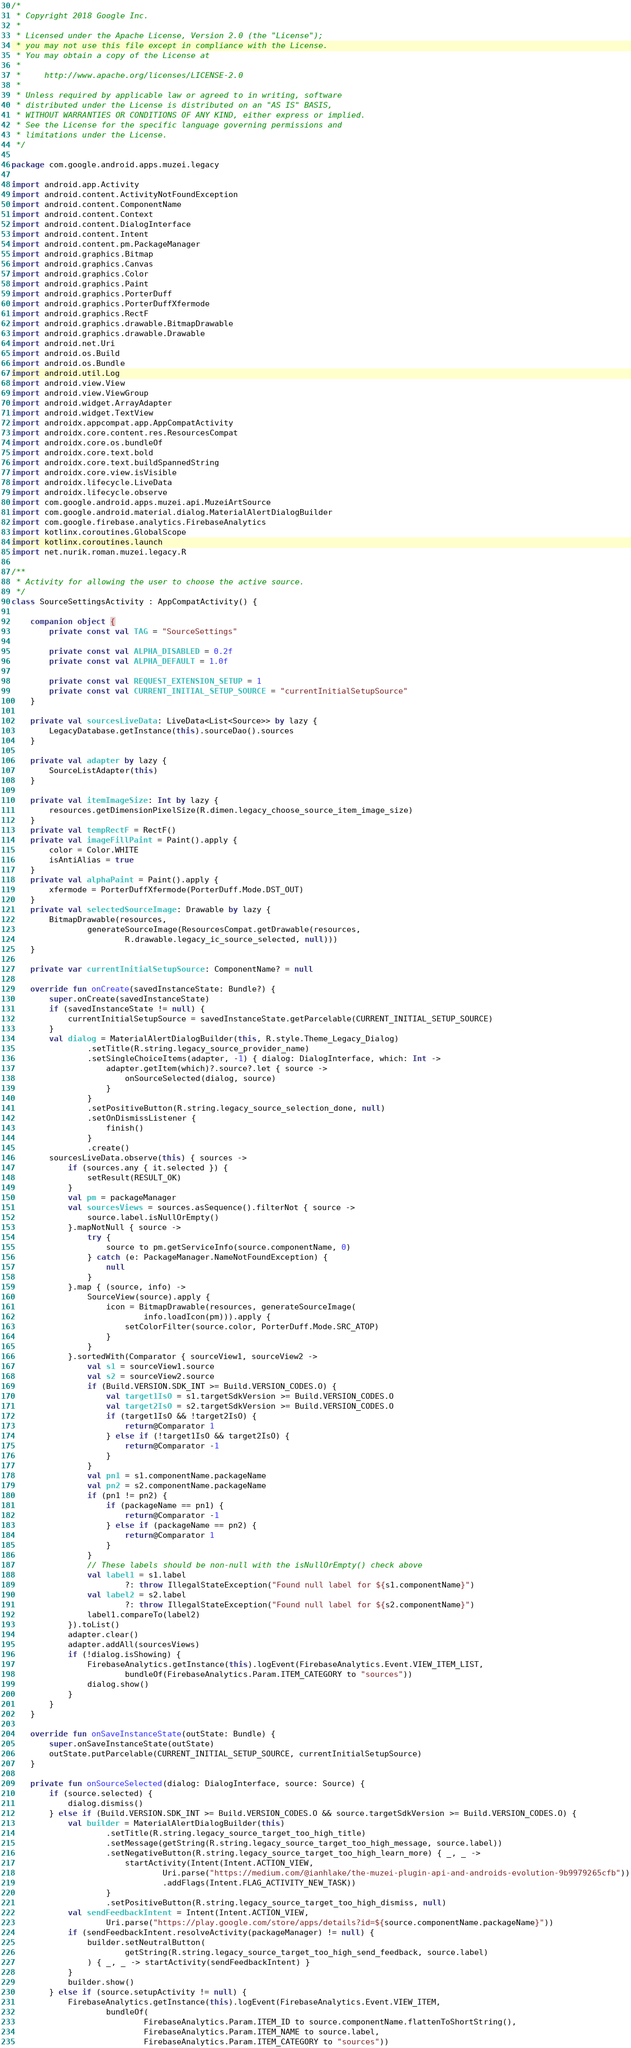<code> <loc_0><loc_0><loc_500><loc_500><_Kotlin_>/*
 * Copyright 2018 Google Inc.
 *
 * Licensed under the Apache License, Version 2.0 (the "License");
 * you may not use this file except in compliance with the License.
 * You may obtain a copy of the License at
 *
 *     http://www.apache.org/licenses/LICENSE-2.0
 *
 * Unless required by applicable law or agreed to in writing, software
 * distributed under the License is distributed on an "AS IS" BASIS,
 * WITHOUT WARRANTIES OR CONDITIONS OF ANY KIND, either express or implied.
 * See the License for the specific language governing permissions and
 * limitations under the License.
 */

package com.google.android.apps.muzei.legacy

import android.app.Activity
import android.content.ActivityNotFoundException
import android.content.ComponentName
import android.content.Context
import android.content.DialogInterface
import android.content.Intent
import android.content.pm.PackageManager
import android.graphics.Bitmap
import android.graphics.Canvas
import android.graphics.Color
import android.graphics.Paint
import android.graphics.PorterDuff
import android.graphics.PorterDuffXfermode
import android.graphics.RectF
import android.graphics.drawable.BitmapDrawable
import android.graphics.drawable.Drawable
import android.net.Uri
import android.os.Build
import android.os.Bundle
import android.util.Log
import android.view.View
import android.view.ViewGroup
import android.widget.ArrayAdapter
import android.widget.TextView
import androidx.appcompat.app.AppCompatActivity
import androidx.core.content.res.ResourcesCompat
import androidx.core.os.bundleOf
import androidx.core.text.bold
import androidx.core.text.buildSpannedString
import androidx.core.view.isVisible
import androidx.lifecycle.LiveData
import androidx.lifecycle.observe
import com.google.android.apps.muzei.api.MuzeiArtSource
import com.google.android.material.dialog.MaterialAlertDialogBuilder
import com.google.firebase.analytics.FirebaseAnalytics
import kotlinx.coroutines.GlobalScope
import kotlinx.coroutines.launch
import net.nurik.roman.muzei.legacy.R

/**
 * Activity for allowing the user to choose the active source.
 */
class SourceSettingsActivity : AppCompatActivity() {

    companion object {
        private const val TAG = "SourceSettings"

        private const val ALPHA_DISABLED = 0.2f
        private const val ALPHA_DEFAULT = 1.0f

        private const val REQUEST_EXTENSION_SETUP = 1
        private const val CURRENT_INITIAL_SETUP_SOURCE = "currentInitialSetupSource"
    }

    private val sourcesLiveData: LiveData<List<Source>> by lazy {
        LegacyDatabase.getInstance(this).sourceDao().sources
    }

    private val adapter by lazy {
        SourceListAdapter(this)
    }

    private val itemImageSize: Int by lazy {
        resources.getDimensionPixelSize(R.dimen.legacy_choose_source_item_image_size)
    }
    private val tempRectF = RectF()
    private val imageFillPaint = Paint().apply {
        color = Color.WHITE
        isAntiAlias = true
    }
    private val alphaPaint = Paint().apply {
        xfermode = PorterDuffXfermode(PorterDuff.Mode.DST_OUT)
    }
    private val selectedSourceImage: Drawable by lazy {
        BitmapDrawable(resources,
                generateSourceImage(ResourcesCompat.getDrawable(resources,
                        R.drawable.legacy_ic_source_selected, null)))
    }

    private var currentInitialSetupSource: ComponentName? = null

    override fun onCreate(savedInstanceState: Bundle?) {
        super.onCreate(savedInstanceState)
        if (savedInstanceState != null) {
            currentInitialSetupSource = savedInstanceState.getParcelable(CURRENT_INITIAL_SETUP_SOURCE)
        }
        val dialog = MaterialAlertDialogBuilder(this, R.style.Theme_Legacy_Dialog)
                .setTitle(R.string.legacy_source_provider_name)
                .setSingleChoiceItems(adapter, -1) { dialog: DialogInterface, which: Int ->
                    adapter.getItem(which)?.source?.let { source ->
                        onSourceSelected(dialog, source)
                    }
                }
                .setPositiveButton(R.string.legacy_source_selection_done, null)
                .setOnDismissListener {
                    finish()
                }
                .create()
        sourcesLiveData.observe(this) { sources ->
            if (sources.any { it.selected }) {
                setResult(RESULT_OK)
            }
            val pm = packageManager
            val sourcesViews = sources.asSequence().filterNot { source ->
                source.label.isNullOrEmpty()
            }.mapNotNull { source ->
                try {
                    source to pm.getServiceInfo(source.componentName, 0)
                } catch (e: PackageManager.NameNotFoundException) {
                    null
                }
            }.map { (source, info) ->
                SourceView(source).apply {
                    icon = BitmapDrawable(resources, generateSourceImage(
                            info.loadIcon(pm))).apply {
                        setColorFilter(source.color, PorterDuff.Mode.SRC_ATOP)
                    }
                }
            }.sortedWith(Comparator { sourceView1, sourceView2 ->
                val s1 = sourceView1.source
                val s2 = sourceView2.source
                if (Build.VERSION.SDK_INT >= Build.VERSION_CODES.O) {
                    val target1IsO = s1.targetSdkVersion >= Build.VERSION_CODES.O
                    val target2IsO = s2.targetSdkVersion >= Build.VERSION_CODES.O
                    if (target1IsO && !target2IsO) {
                        return@Comparator 1
                    } else if (!target1IsO && target2IsO) {
                        return@Comparator -1
                    }
                }
                val pn1 = s1.componentName.packageName
                val pn2 = s2.componentName.packageName
                if (pn1 != pn2) {
                    if (packageName == pn1) {
                        return@Comparator -1
                    } else if (packageName == pn2) {
                        return@Comparator 1
                    }
                }
                // These labels should be non-null with the isNullOrEmpty() check above
                val label1 = s1.label
                        ?: throw IllegalStateException("Found null label for ${s1.componentName}")
                val label2 = s2.label
                        ?: throw IllegalStateException("Found null label for ${s2.componentName}")
                label1.compareTo(label2)
            }).toList()
            adapter.clear()
            adapter.addAll(sourcesViews)
            if (!dialog.isShowing) {
                FirebaseAnalytics.getInstance(this).logEvent(FirebaseAnalytics.Event.VIEW_ITEM_LIST,
                        bundleOf(FirebaseAnalytics.Param.ITEM_CATEGORY to "sources"))
                dialog.show()
            }
        }
    }

    override fun onSaveInstanceState(outState: Bundle) {
        super.onSaveInstanceState(outState)
        outState.putParcelable(CURRENT_INITIAL_SETUP_SOURCE, currentInitialSetupSource)
    }

    private fun onSourceSelected(dialog: DialogInterface, source: Source) {
        if (source.selected) {
            dialog.dismiss()
        } else if (Build.VERSION.SDK_INT >= Build.VERSION_CODES.O && source.targetSdkVersion >= Build.VERSION_CODES.O) {
            val builder = MaterialAlertDialogBuilder(this)
                    .setTitle(R.string.legacy_source_target_too_high_title)
                    .setMessage(getString(R.string.legacy_source_target_too_high_message, source.label))
                    .setNegativeButton(R.string.legacy_source_target_too_high_learn_more) { _, _ ->
                        startActivity(Intent(Intent.ACTION_VIEW,
                                Uri.parse("https://medium.com/@ianhlake/the-muzei-plugin-api-and-androids-evolution-9b9979265cfb"))
                                .addFlags(Intent.FLAG_ACTIVITY_NEW_TASK))
                    }
                    .setPositiveButton(R.string.legacy_source_target_too_high_dismiss, null)
            val sendFeedbackIntent = Intent(Intent.ACTION_VIEW,
                    Uri.parse("https://play.google.com/store/apps/details?id=${source.componentName.packageName}"))
            if (sendFeedbackIntent.resolveActivity(packageManager) != null) {
                builder.setNeutralButton(
                        getString(R.string.legacy_source_target_too_high_send_feedback, source.label)
                ) { _, _ -> startActivity(sendFeedbackIntent) }
            }
            builder.show()
        } else if (source.setupActivity != null) {
            FirebaseAnalytics.getInstance(this).logEvent(FirebaseAnalytics.Event.VIEW_ITEM,
                    bundleOf(
                            FirebaseAnalytics.Param.ITEM_ID to source.componentName.flattenToShortString(),
                            FirebaseAnalytics.Param.ITEM_NAME to source.label,
                            FirebaseAnalytics.Param.ITEM_CATEGORY to "sources"))</code> 